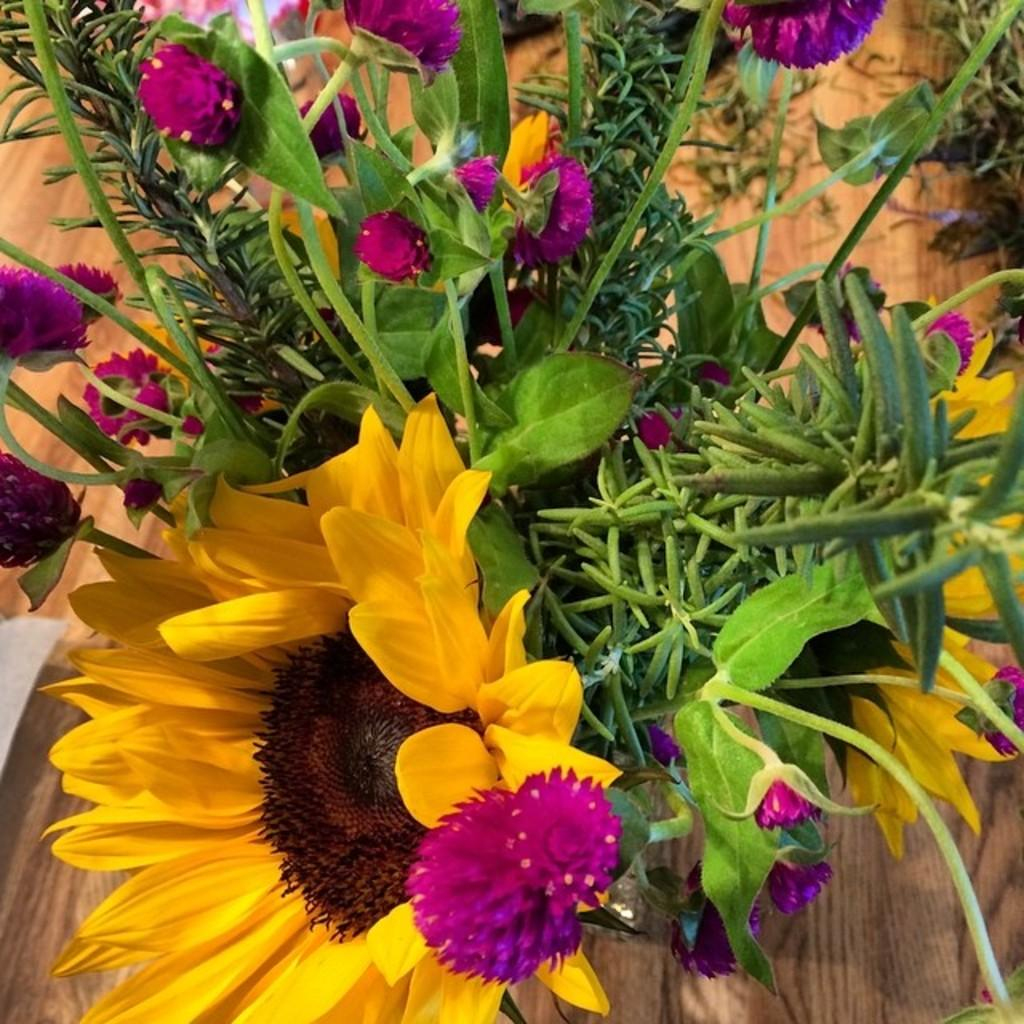What type of plant is in the image? The plant in the image has sunflowers and pink flowers. What colors are present in the flowers of the plant? The flowers of the plant have sunflowers and pink flowers. What is the surface beneath the plant? The plant is on a wooden floor. What type of oil is being used to form the chickens in the image? There are no chickens present in the image, and therefore no oil or form is involved. 